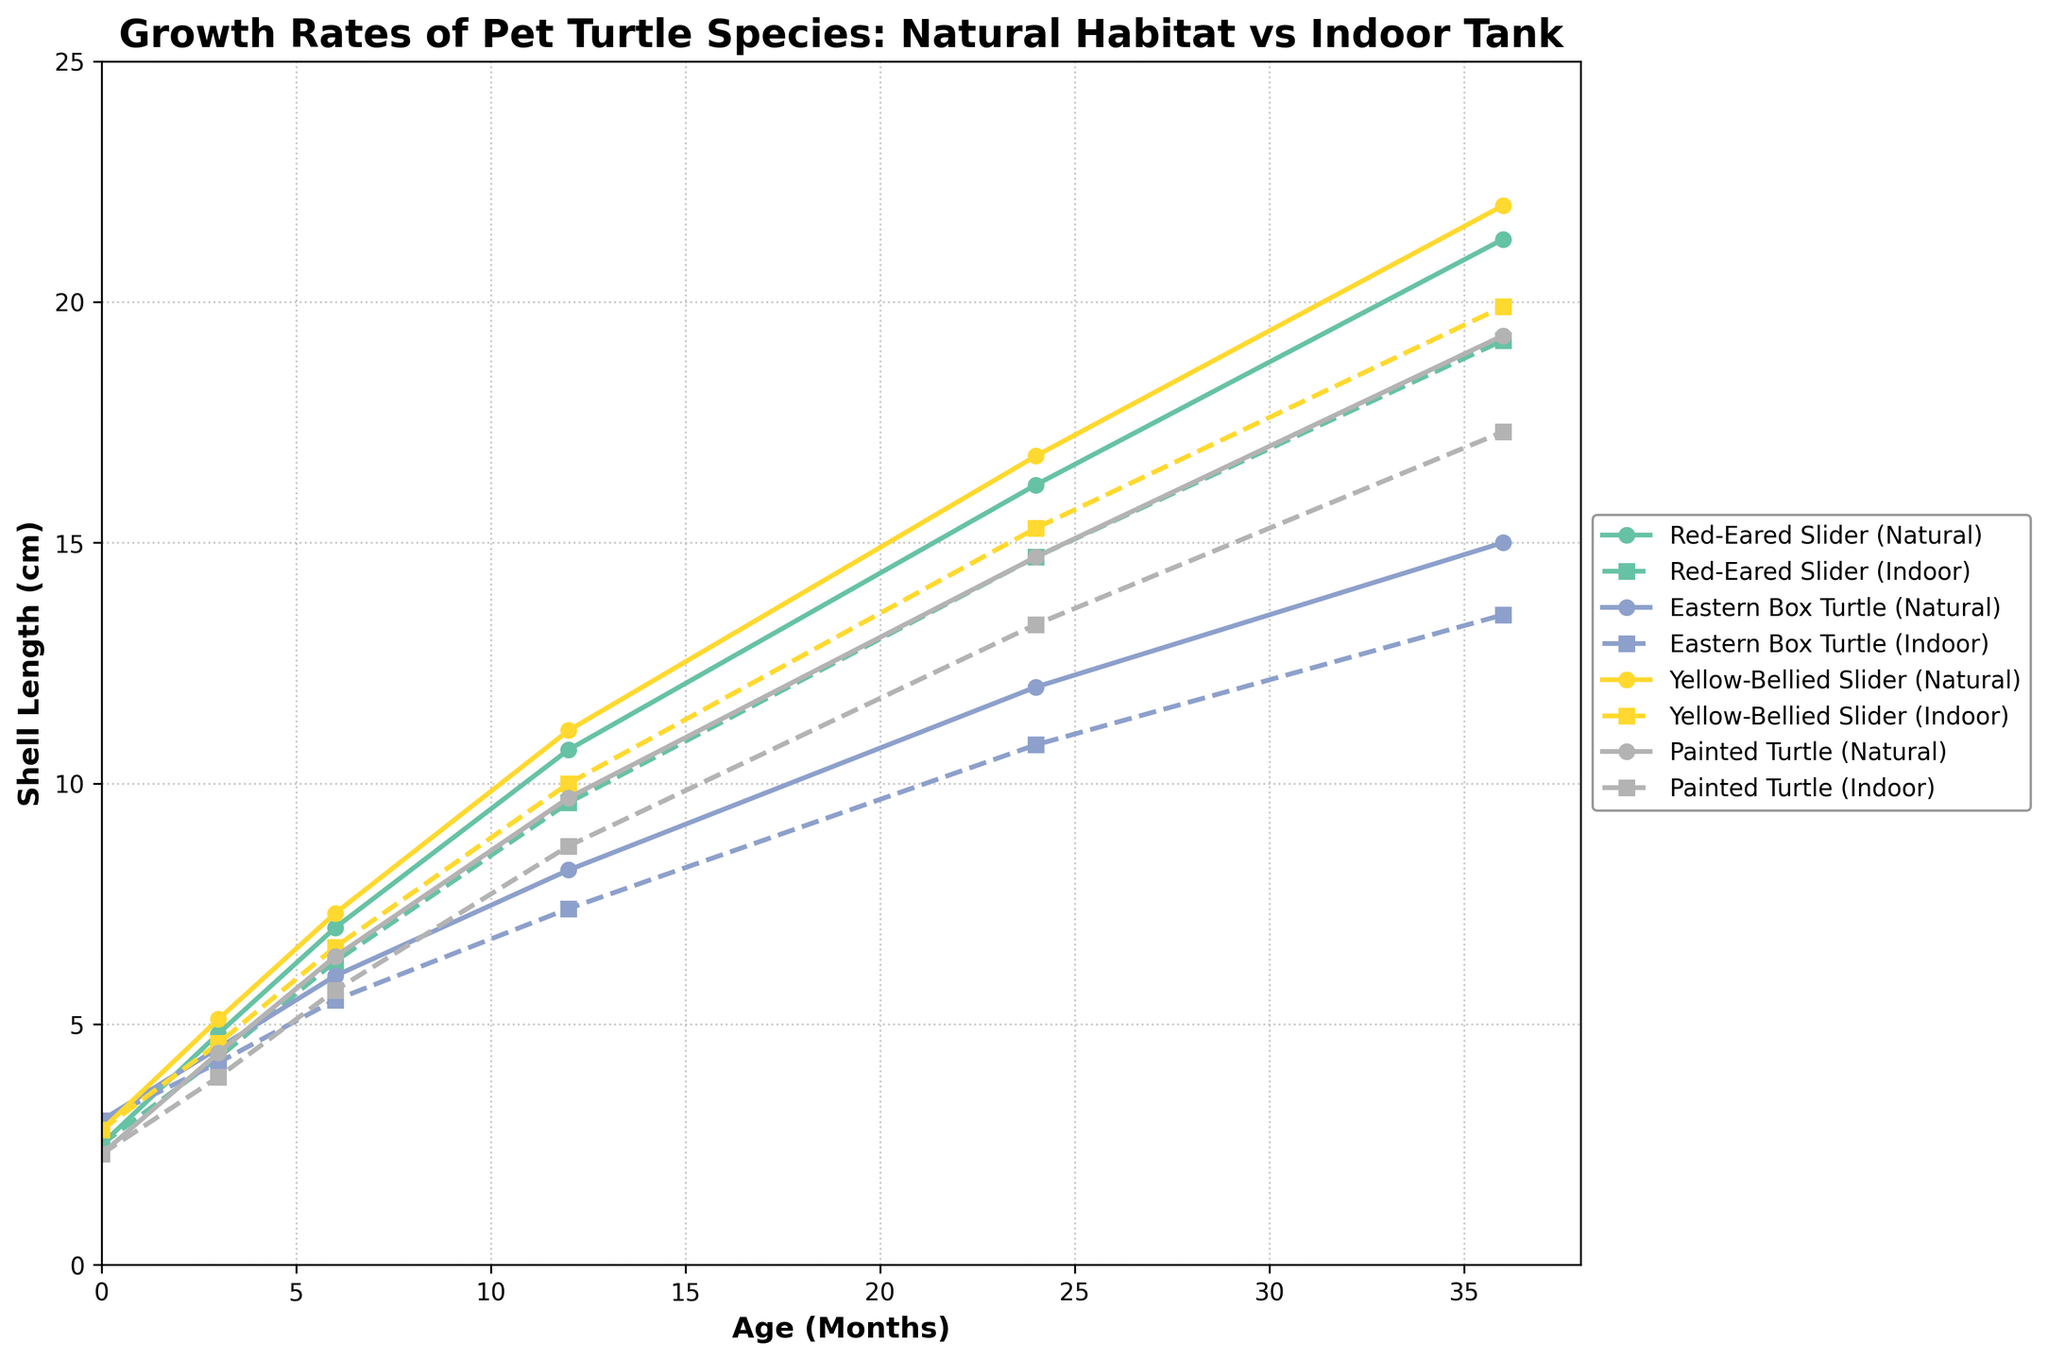What is the difference in the shell length of Red-Eared Slider turtles at 24 months between Natural Habitat and Indoor Tank conditions? To find the difference, locate the shell lengths at 24 months for Red-Eared Slider turtles under Natural Habitat and Indoor Tank conditions. Subtract the Indoor Tank value from the Natural Habitat value. 16.2 cm (Natural Habitat) - 14.7 cm (Indoor Tank) = 1.5 cm
Answer: 1.5 cm Which turtle species shows the most significant growth differential between Natural Habitat and Indoor Tank conditions at 36 months? For each species, find the shell lengths at 36 months for both conditions and calculate the differences. Compare these differences to identify the largest one. Differences for each species: Red-Eared Slider (21.3 - 19.2 = 2.1 cm), Eastern Box Turtle (15.0 - 13.5 = 1.5 cm), Yellow-Bellied Slider (22.0 - 19.9 = 2.1 cm), Painted Turtle (19.3 - 17.3 = 2.0 cm). The largest difference is for Red-Eared Slider and Yellow-Bellied Slider (2.1 cm).
Answer: Red-Eared Slider and Yellow-Bellied Slider (2.1 cm) At what age do Painted Turtles kept in Natural Habitat first reach a shell length of approximately 10 cm? Identify the ages for Painted Turtles under Natural Habitat conditions and find when the shell length is just below or closest to 10 cm. The shell length at 12 months is 9.7 cm, which is the closest to 10 cm without exceeding it.
Answer: 12 months Compare the initial shell lengths (at 0 months) across all species. Which one has the longest shell length? Look at the initial (0 months) shell lengths across all species under any condition. Compare the values. Red-Eared Slider: 2.5 cm, Eastern Box Turtle: 3.0 cm, Yellow-Bellied Slider: 2.8 cm, Painted Turtle: 2.3 cm. The Eastern Box Turtle has the longest initial shell length of 3.0 cm.
Answer: Eastern Box Turtle What can be inferred about the growth patterns of turtles in Natural Habitat conditions compared to Indoor Tank conditions? Evaluate the overall trends in the lines representing Natural Habitat and Indoor Tank conditions for each turtle species. The growth rates in Natural Habitat appear to be consistently higher for all species, indicating that Natural Habitat conditions generally promote better growth compared to Indoor Tank conditions.
Answer: Natural Habitat promotes better growth What is the average shell length of Yellow-Bellied Slider turtles at 12 months across both Natural Habitat and Indoor Tank conditions? Find the shell lengths of Yellow-Bellied Slider turtles at 12 months under both conditions and calculate the average. (11.1 cm + 10.0 cm) / 2 = 10.55 cm.
Answer: 10.55 cm How does the growth rate of Eastern Box Turtle in the first 6 months under Natural Habitat conditions compare to the last 6 months within the first year? Calculate the shell length increase of Eastern Box Turtle from 0 to 6 months and from 6 to 12 months under Natural Habitat conditions. First 6 months: 6.0 cm - 3.0 cm = 3.0 cm. Last 6 months: 8.2 cm - 6.0 cm = 2.2 cm. The first 6 months have a higher growth rate (3.0 cm) compared to the last 6 months of the year (2.2 cm).
Answer: Higher in the first 6 months Which species shows the least difference in shell length between Natural Habitat and Indoor Tank at 3 months? For each species, find the difference in shell lengths at 3 months between Natural Habitat and Indoor Tank conditions and compare them. Red-Eared Slider: 4.8 - 4.3 = 0.5 cm, Eastern Box Turtle: 4.5 - 4.2 = 0.3 cm, Yellow-Bellied Slider: 5.1 - 4.6 = 0.5 cm, Painted Turtle: 4.4 - 3.9 = 0.5 cm. The Eastern Box Turtle shows the least difference (0.3 cm).
Answer: Eastern Box Turtle 